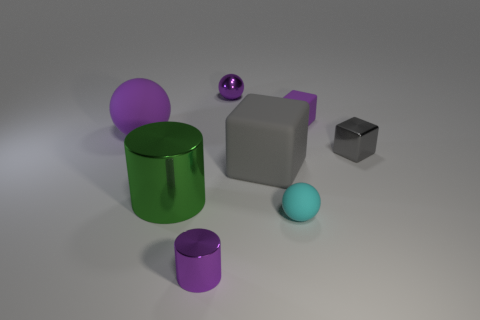There is a small purple metal object that is on the right side of the purple cylinder; does it have the same shape as the small purple object in front of the large matte sphere?
Provide a short and direct response. No. There is a matte object that is in front of the large thing that is to the right of the small purple metal object that is behind the small purple matte object; what is its size?
Offer a very short reply. Small. How big is the ball to the left of the tiny purple metal cylinder?
Ensure brevity in your answer.  Large. There is a tiny ball that is on the left side of the tiny cyan matte sphere; what is its material?
Ensure brevity in your answer.  Metal. How many blue objects are matte cubes or small metallic things?
Offer a very short reply. 0. Do the tiny purple cube and the small object left of the purple shiny ball have the same material?
Your answer should be compact. No. Are there an equal number of cubes that are to the left of the large rubber ball and small metallic cubes in front of the metal block?
Offer a terse response. Yes. Do the purple rubber sphere and the shiny block in front of the large sphere have the same size?
Offer a very short reply. No. Is the number of shiny objects that are on the left side of the big gray thing greater than the number of large green cylinders?
Your answer should be compact. Yes. What number of rubber blocks have the same size as the green object?
Your answer should be very brief. 1. 